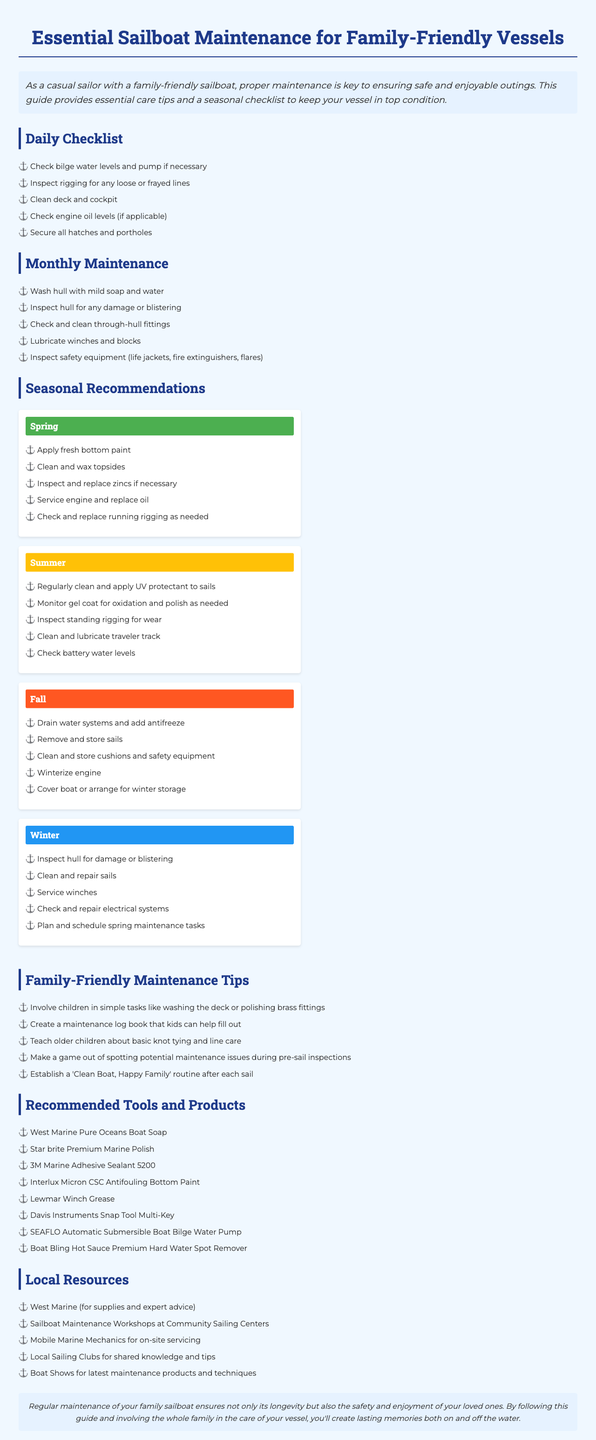What is the title of the brochure? The title is provided in the document to emphasize the topic covered.
Answer: Essential Sailboat Maintenance for Family-Friendly Vessels How many items are on the daily checklist? The daily checklist section includes a specific number of items listed.
Answer: 5 What maintenance task is recommended for spring? The document specifies particular tasks to be performed in the spring season for maintenance.
Answer: Apply fresh bottom paint What product is suggested for cleaning hard water spots? The recommended tools and products section contains specific items to be used during maintenance.
Answer: Boat Bling Hot Sauce Premium Hard Water Spot Remover Which season involves winterizing the engine? The seasonal recommendations indicate tasks that should be performed during winter.
Answer: Fall What is one way to involve children in maintenance? The family-friendly maintenance tips suggest activities aimed at engaging children in a fun way.
Answer: Washing the deck What type of maintenance should be performed monthly? The document outlines a specific section that covers maintenance tasks to be done monthly.
Answer: Wash hull with mild soap and water Which local resource is mentioned for expert advice? Local resources offer support and tools for maintaining the sailboat as cited in the document.
Answer: West Marine 